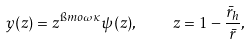Convert formula to latex. <formula><loc_0><loc_0><loc_500><loc_500>y ( z ) = z ^ { \i m o \omega \kappa } \psi ( z ) , \quad z = 1 - \frac { { \bar { r } } _ { h } } { \bar { r } } ,</formula> 